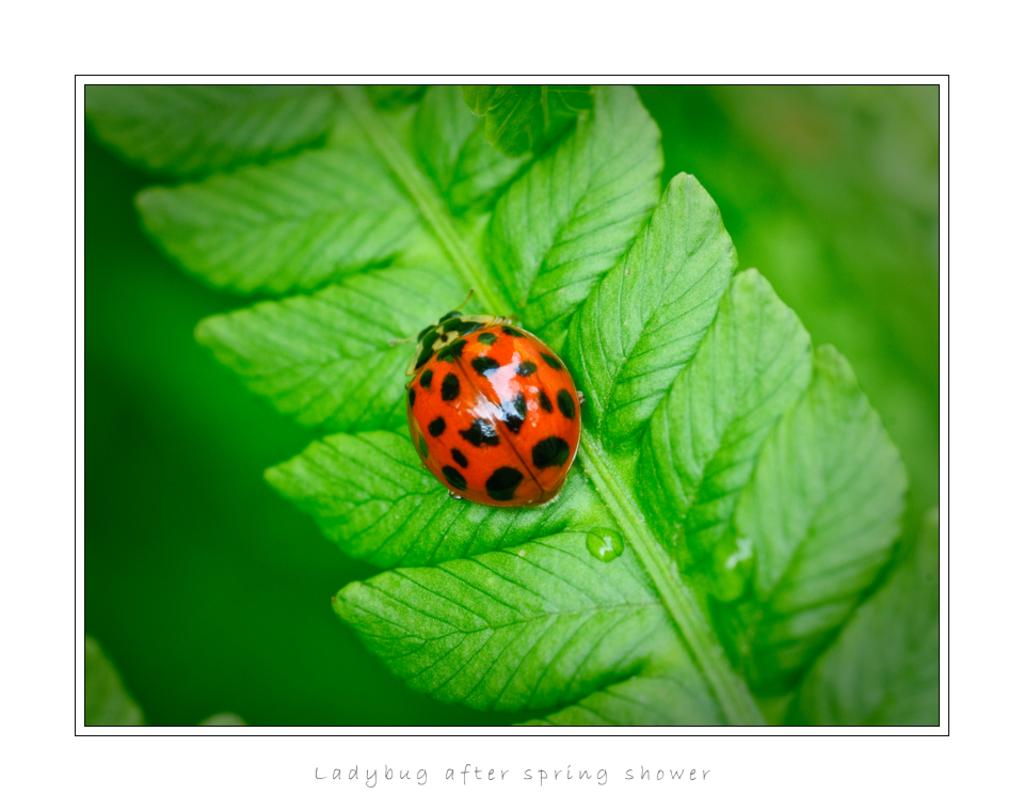What type of creature is in the image? There is an insect in the image. What colors can be seen on the insect? The insect has an orange and black color combination. Where is the insect located in the image? The insect is on a green leaf. What type of plant does the leaf belong to? The leaf is from a tree. What else can be seen in the background of the image? There are other objects in the background of the image. How many apples are hanging from the tree in the image? There are no apples visible in the image; it only shows an insect on a green leaf from a tree. What type of mitten is the insect wearing in the image? There is no mitten present in the image, as insects do not wear clothing. 